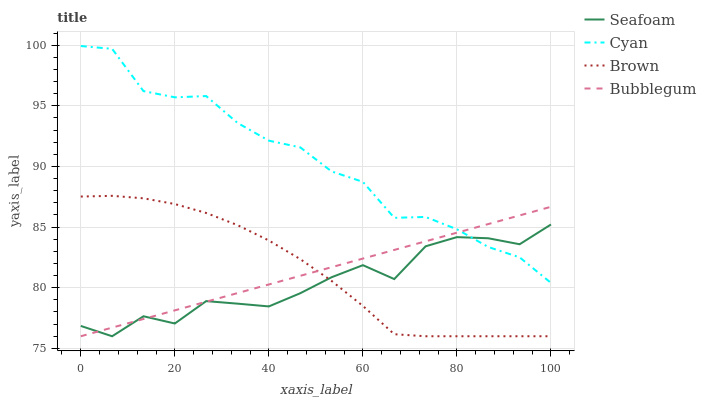Does Seafoam have the minimum area under the curve?
Answer yes or no. Yes. Does Cyan have the maximum area under the curve?
Answer yes or no. Yes. Does Bubblegum have the minimum area under the curve?
Answer yes or no. No. Does Bubblegum have the maximum area under the curve?
Answer yes or no. No. Is Bubblegum the smoothest?
Answer yes or no. Yes. Is Seafoam the roughest?
Answer yes or no. Yes. Is Seafoam the smoothest?
Answer yes or no. No. Is Bubblegum the roughest?
Answer yes or no. No. Does Seafoam have the lowest value?
Answer yes or no. Yes. Does Cyan have the highest value?
Answer yes or no. Yes. Does Bubblegum have the highest value?
Answer yes or no. No. Is Brown less than Cyan?
Answer yes or no. Yes. Is Cyan greater than Brown?
Answer yes or no. Yes. Does Cyan intersect Seafoam?
Answer yes or no. Yes. Is Cyan less than Seafoam?
Answer yes or no. No. Is Cyan greater than Seafoam?
Answer yes or no. No. Does Brown intersect Cyan?
Answer yes or no. No. 